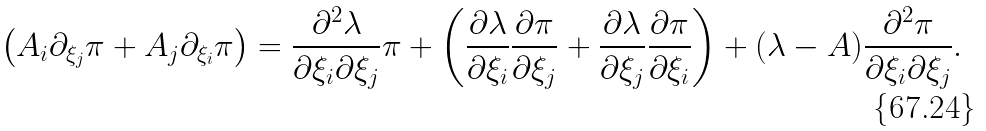<formula> <loc_0><loc_0><loc_500><loc_500>\left ( A _ { i } \partial _ { \xi _ { j } } \pi + A _ { j } \partial _ { \xi _ { i } } \pi \right ) = \frac { \partial ^ { 2 } \lambda } { \partial \xi _ { i } \partial \xi _ { j } } \pi + \left ( \frac { \partial \lambda } { \partial \xi _ { i } } \frac { \partial \pi } { \partial \xi _ { j } } + \frac { \partial \lambda } { \partial \xi _ { j } } \frac { \partial \pi } { \partial \xi _ { i } } \right ) + ( \lambda - A ) \frac { \partial ^ { 2 } \pi } { \partial \xi _ { i } \partial \xi _ { j } } .</formula> 